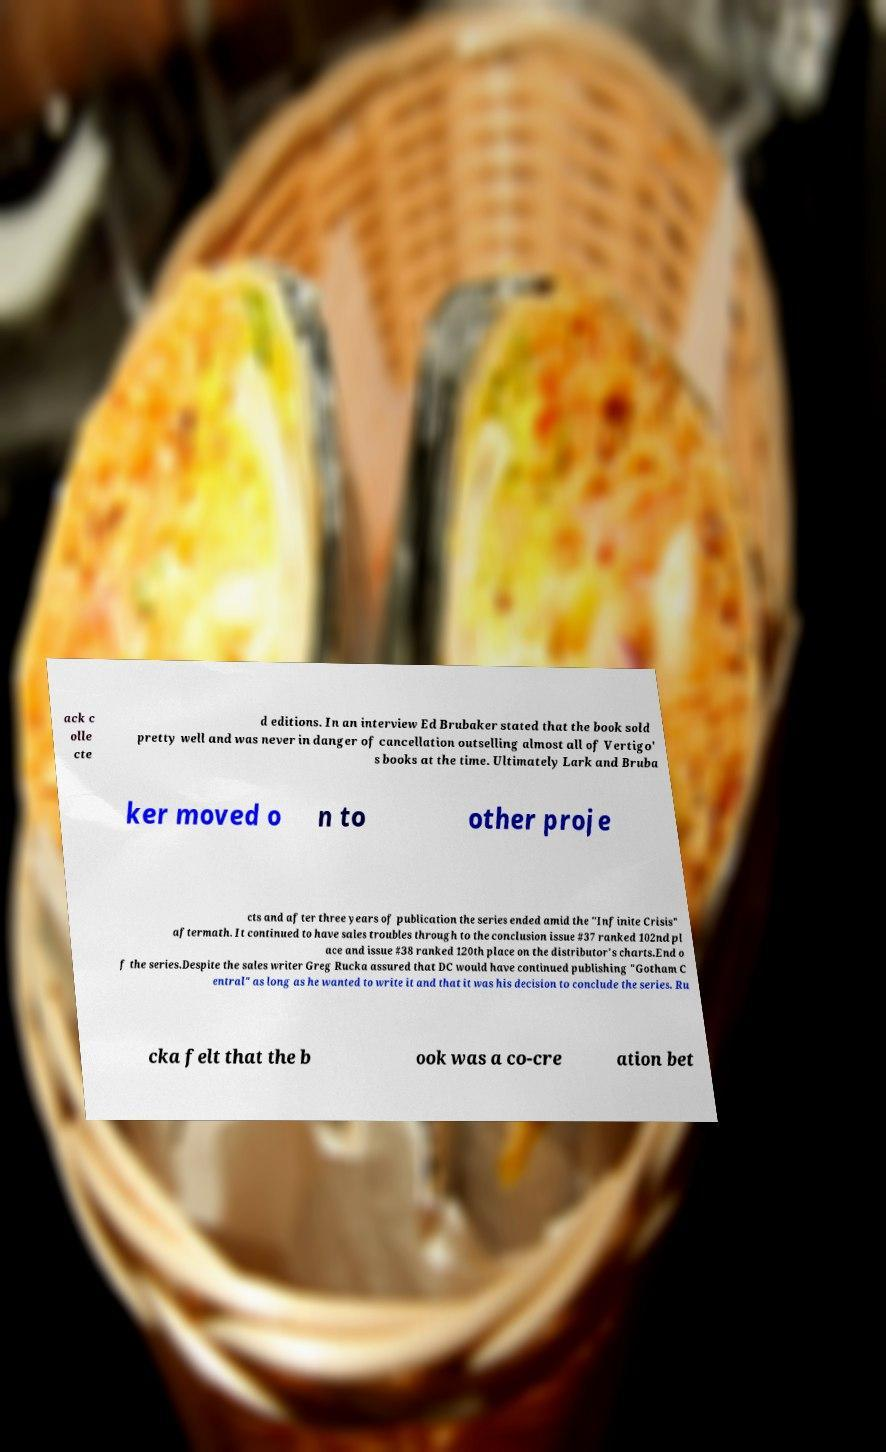Please identify and transcribe the text found in this image. ack c olle cte d editions. In an interview Ed Brubaker stated that the book sold pretty well and was never in danger of cancellation outselling almost all of Vertigo' s books at the time. Ultimately Lark and Bruba ker moved o n to other proje cts and after three years of publication the series ended amid the "Infinite Crisis" aftermath. It continued to have sales troubles through to the conclusion issue #37 ranked 102nd pl ace and issue #38 ranked 120th place on the distributor's charts.End o f the series.Despite the sales writer Greg Rucka assured that DC would have continued publishing "Gotham C entral" as long as he wanted to write it and that it was his decision to conclude the series. Ru cka felt that the b ook was a co-cre ation bet 